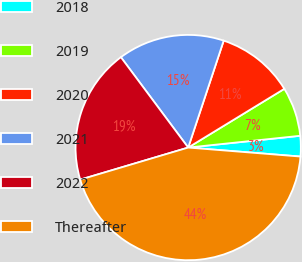Convert chart to OTSL. <chart><loc_0><loc_0><loc_500><loc_500><pie_chart><fcel>2018<fcel>2019<fcel>2020<fcel>2021<fcel>2022<fcel>Thereafter<nl><fcel>2.94%<fcel>7.06%<fcel>11.17%<fcel>15.29%<fcel>19.41%<fcel>44.13%<nl></chart> 